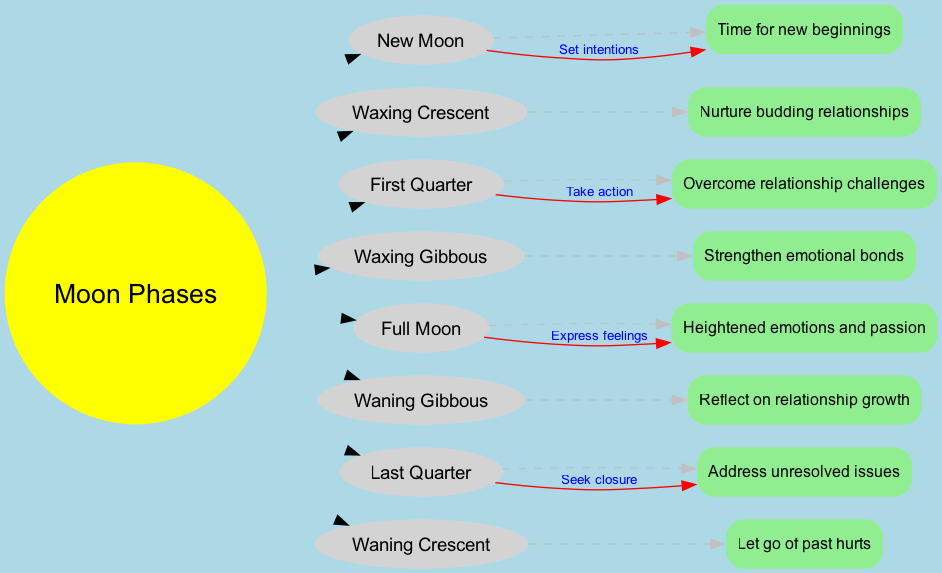What is placed at the center of the diagram? The center node represents the overall theme of the diagram, which is explicitly stated as "Moon Phases." Therefore, identifying the central concept directly answers the question.
Answer: Moon Phases How many phases of the Moon are shown in the inner circle? The inner circle contains the eight phases of the Moon, and by counting each listed phase, we confirm the total.
Answer: Eight What is the influence associated with the Full Moon? By examining the outer circle, we locate the Full Moon and see its corresponding influence, which is specified next to it.
Answer: Heightened emotions and passion What action is suggested during the First Quarter phase? Looking at the connection between the First Quarter and its associated influence reveals that the expected action during this phase is to "Take action."
Answer: Take action Which phase suggests nurturing budding relationships? Searching through the inner circle, we find the phase that corresponds with nurturing relationships, identifying it specifically with the label underneath.
Answer: Waxing Crescent What does the Last Quarter phase advise individuals to do? The diagram connects the Last Quarter phase with its respective action, prompting individuals to address certain issues and seek resolution accordingly.
Answer: Seek closure How many connections are depicted between the inner and outer circles? The connections show how the phases relate to their influences. By counting the individual linking lines between the inner and outer nodes, we determine the total.
Answer: Four What is the relationship between the New Moon and new beginnings? We observe that the New Moon directly connects to the idea of setting intentions, indicating the role that this phase plays in terms of new beginnings.
Answer: Set intentions What is the influence tied to the Waning Crescent? To respond to this question, we check the outer circle and find the influence linked with the Waning Crescent phase stated below it.
Answer: Let go of past hurts 